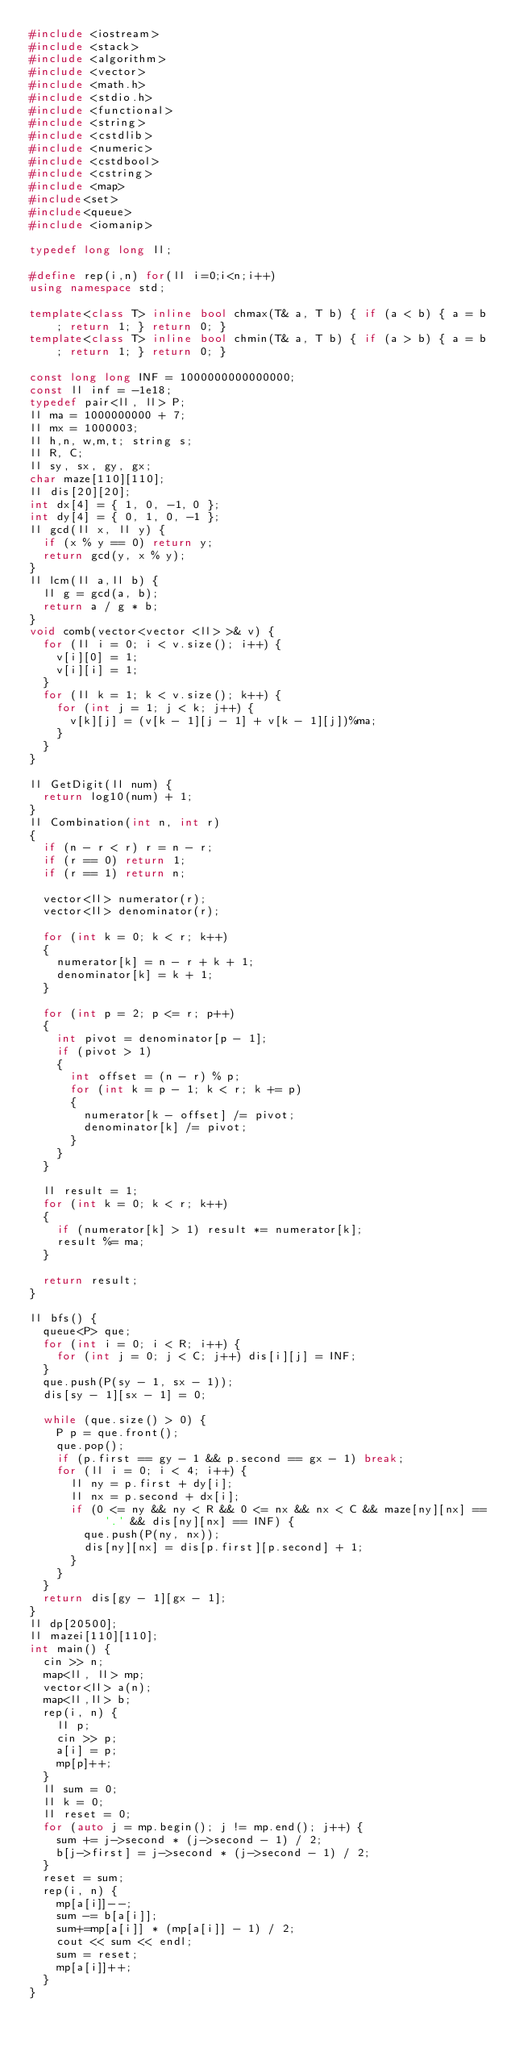Convert code to text. <code><loc_0><loc_0><loc_500><loc_500><_C++_>#include <iostream>
#include <stack>
#include <algorithm>
#include <vector>
#include <math.h>
#include <stdio.h>
#include <functional>
#include <string>
#include <cstdlib>
#include <numeric>
#include <cstdbool>
#include <cstring>
#include <map> 
#include<set>
#include<queue>
#include <iomanip>

typedef long long ll;

#define rep(i,n) for(ll i=0;i<n;i++)
using namespace std;

template<class T> inline bool chmax(T& a, T b) { if (a < b) { a = b; return 1; } return 0; }
template<class T> inline bool chmin(T& a, T b) { if (a > b) { a = b; return 1; } return 0; }

const long long INF = 1000000000000000;
const ll inf = -1e18;
typedef pair<ll, ll> P;
ll ma = 1000000000 + 7;
ll mx = 1000003;
ll h,n, w,m,t; string s;
ll R, C;
ll sy, sx, gy, gx;
char maze[110][110];
ll dis[20][20];
int dx[4] = { 1, 0, -1, 0 };
int dy[4] = { 0, 1, 0, -1 };
ll gcd(ll x, ll y) {
	if (x % y == 0) return y;
	return gcd(y, x % y);
}
ll lcm(ll a,ll b) {
	ll g = gcd(a, b);
	return a / g * b;
}
void comb(vector<vector <ll> >& v) {
	for (ll i = 0; i < v.size(); i++) {
		v[i][0] = 1;
		v[i][i] = 1;
	}
	for (ll k = 1; k < v.size(); k++) {
		for (int j = 1; j < k; j++) {
			v[k][j] = (v[k - 1][j - 1] + v[k - 1][j])%ma;
		}
	}
}

ll GetDigit(ll num) {
	return log10(num) + 1;
}
ll Combination(int n, int r)
{
	if (n - r < r) r = n - r;
	if (r == 0) return 1;
	if (r == 1) return n;

	vector<ll> numerator(r);
	vector<ll> denominator(r);

	for (int k = 0; k < r; k++)
	{
		numerator[k] = n - r + k + 1;
		denominator[k] = k + 1;
	}

	for (int p = 2; p <= r; p++)
	{
		int pivot = denominator[p - 1];
		if (pivot > 1)
		{
			int offset = (n - r) % p;
			for (int k = p - 1; k < r; k += p)
			{
				numerator[k - offset] /= pivot;
				denominator[k] /= pivot;
			}
		}
	}

	ll result = 1;
	for (int k = 0; k < r; k++)
	{
		if (numerator[k] > 1) result *= numerator[k];
		result %= ma;
	}

	return result;
}

ll bfs() {
	queue<P> que;
	for (int i = 0; i < R; i++) {
		for (int j = 0; j < C; j++) dis[i][j] = INF;
	}
	que.push(P(sy - 1, sx - 1));
	dis[sy - 1][sx - 1] = 0;

	while (que.size() > 0) {
		P p = que.front();
		que.pop();
		if (p.first == gy - 1 && p.second == gx - 1) break;
		for (ll i = 0; i < 4; i++) {
			ll ny = p.first + dy[i];
			ll nx = p.second + dx[i];
			if (0 <= ny && ny < R && 0 <= nx && nx < C && maze[ny][nx] == '.' && dis[ny][nx] == INF) {
				que.push(P(ny, nx));
				dis[ny][nx] = dis[p.first][p.second] + 1;
			}
		}
	}
	return dis[gy - 1][gx - 1];
}
ll dp[20500];
ll mazei[110][110];
int main() {
	cin >> n;
	map<ll, ll> mp;
	vector<ll> a(n);
	map<ll,ll> b;
	rep(i, n) {
		ll p;
		cin >> p;
		a[i] = p;
		mp[p]++;
	}
	ll sum = 0;
	ll k = 0;
	ll reset = 0;
	for (auto j = mp.begin(); j != mp.end(); j++) {
		sum += j->second * (j->second - 1) / 2;
		b[j->first] = j->second * (j->second - 1) / 2;
	}
	reset = sum;
	rep(i, n) {
		mp[a[i]]--;
		sum -= b[a[i]];
		sum+=mp[a[i]] * (mp[a[i]] - 1) / 2;
		cout << sum << endl;
		sum = reset;
		mp[a[i]]++;
	}
}</code> 